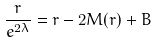<formula> <loc_0><loc_0><loc_500><loc_500>\frac { r } { e ^ { 2 \lambda } } = r - 2 M ( r ) + B</formula> 